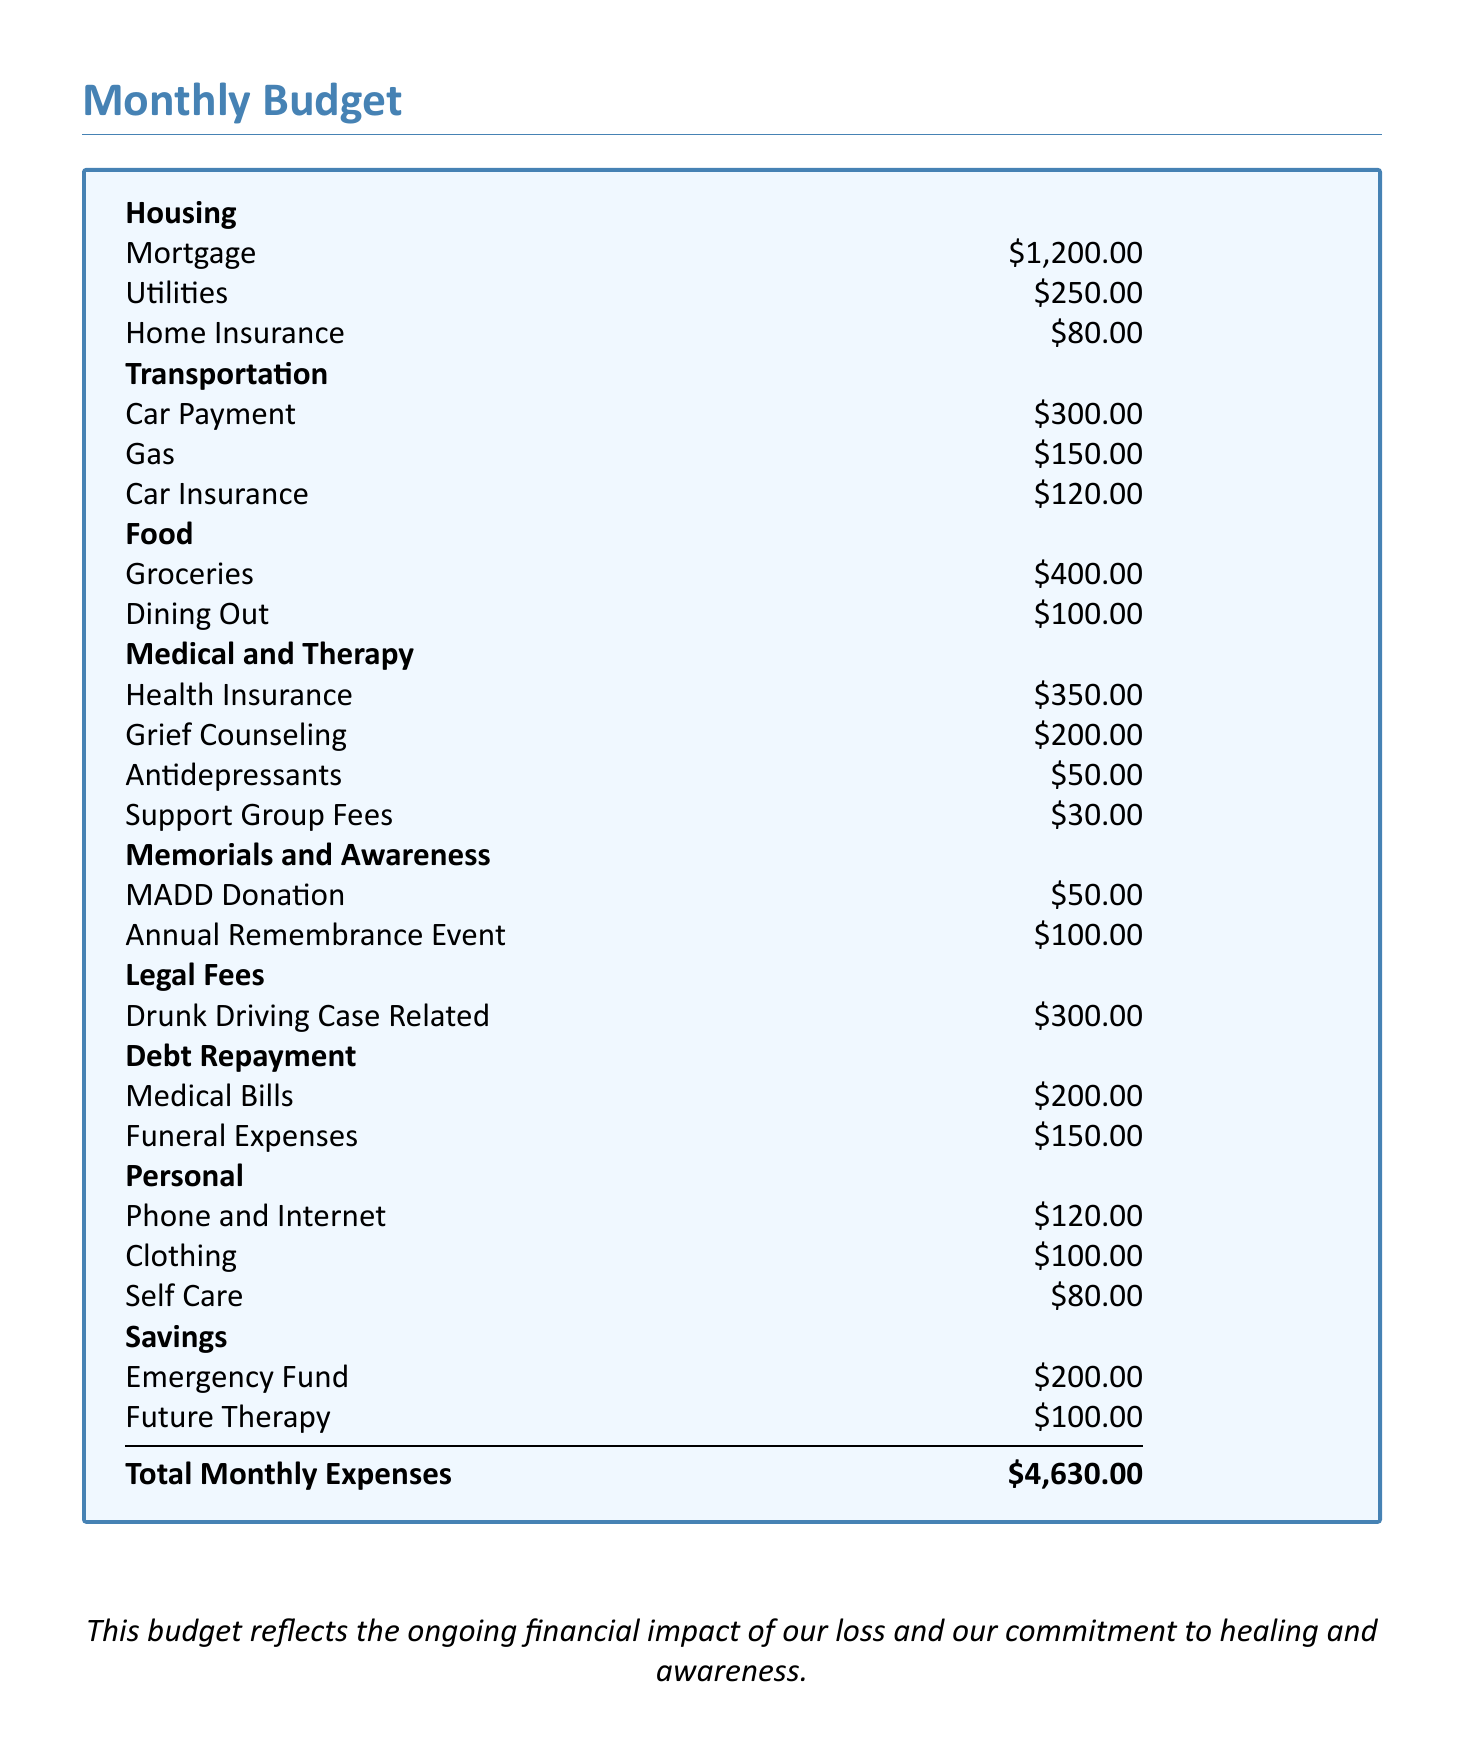what is the total monthly expense? The total monthly expenses are listed at the bottom of the document, adding up all categories.
Answer: $4,630.00 how much is allocated for health insurance? The budget specifies a separate amount listed under Medical and Therapy for health insurance.
Answer: $350.00 what is the cost of grief counseling? Grief counseling is specifically listed as an expense under Medical and Therapy in the budget.
Answer: $200.00 how much is set aside for future therapy? Future therapy is a separate line item under the Savings category in the budget.
Answer: $100.00 how much do the memorials and awareness cost monthly? The document lists the expenses for memorials and awareness as two specific costs under that category.
Answer: $150.00 what is the expense for car insurance? The car insurance amount is listed under the Transportation section of the budget.
Answer: $120.00 what is the total amount spent on medical bills and funeral expenses? This requires adding the two specific expenses listed under Debt Repayment.
Answer: $350.00 how much is allocated for support group fees? The budget specifically states the expense for support group fees in the Medical and Therapy section.
Answer: $30.00 how much is allocated for MADD donation? This amount is explicitly stated under the Memorials and Awareness section of the budget.
Answer: $50.00 